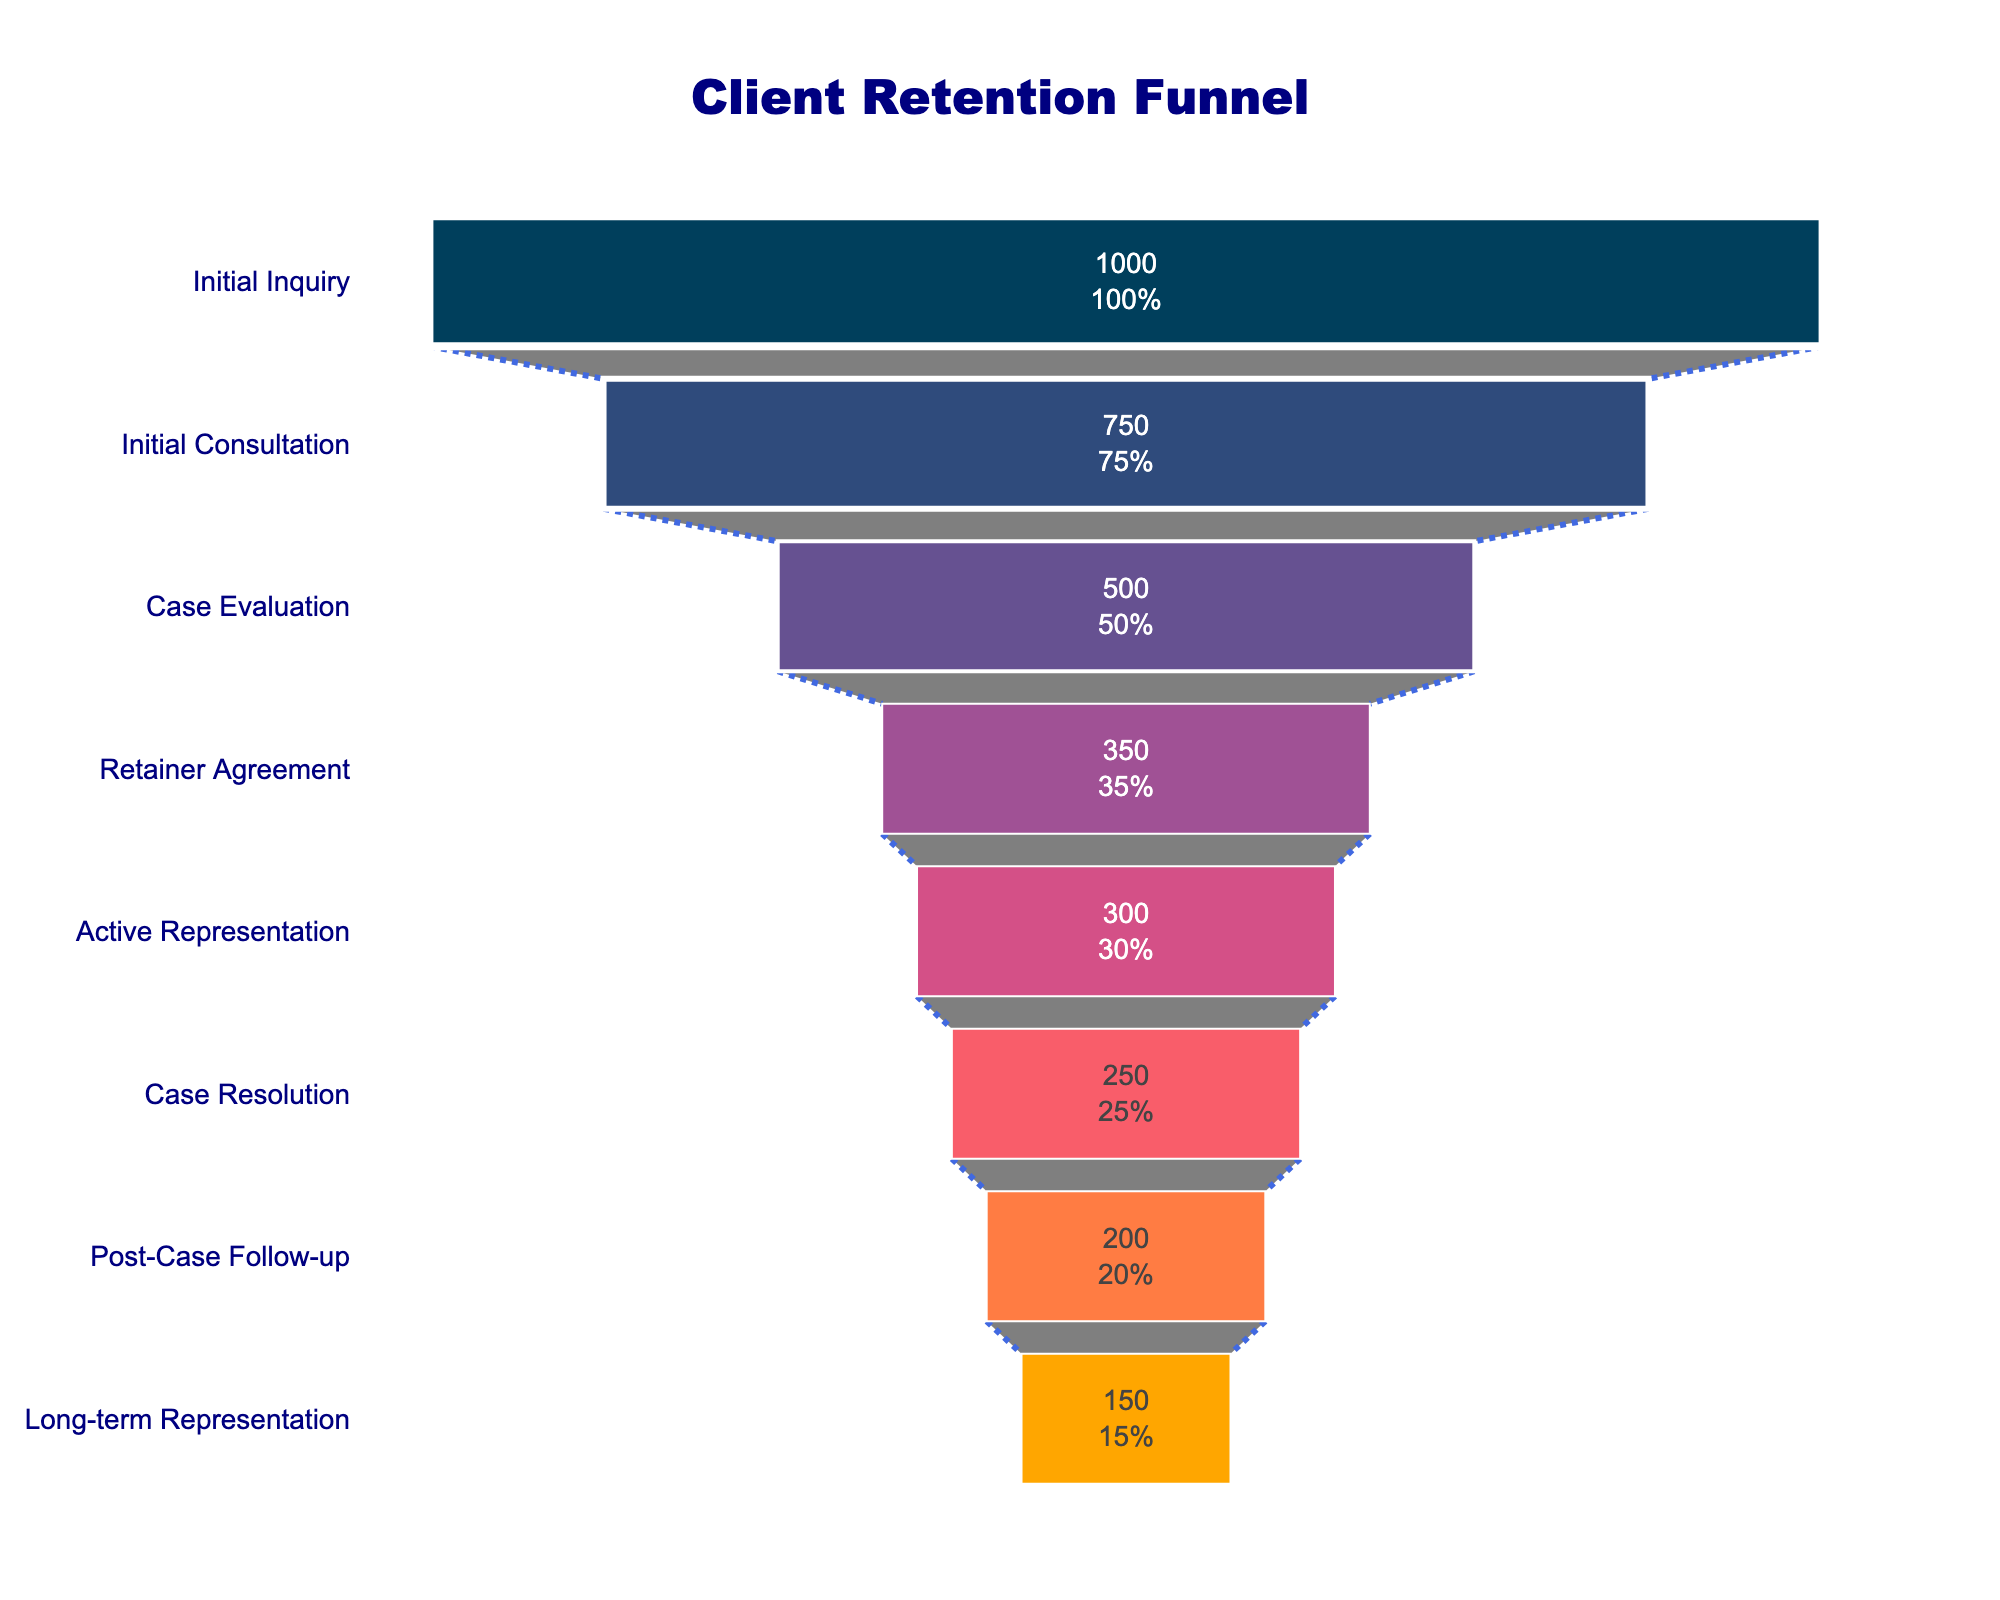What is the title of the funnel chart? The title of the chart is located at the top center. It reads "Client Retention Funnel" in a prominent font.
Answer: Client Retention Funnel How many stages are depicted in the funnel chart? The stages are listed in the funnel chart from top to bottom, indicating evolutionary steps. Counting these stages gives us the total number.
Answer: 8 What is the initial number of clients at the "Initial Inquiry" stage? The value inside the funnel chart at the "Initial Inquiry" stage shows the number of clients.
Answer: 1000 How many clients transition from the "Initial Consultation" to the "Case Evaluation" stage? The number of clients at the "Initial Consultation" stage is given as 750, and at the "Case Evaluation" stage, it is 500. The transition can be calculated by subtracting the number at "Case Evaluation" from "Initial Consultation". 750 - 500 = 250
Answer: 250 Which stage sees the largest drop in the number of clients between two consecutive stages? By comparing the drop in client numbers between each consecutive stage, the largest difference can be identified.
Answer: Initial Inquiry to Initial Consultation What percentage of clients from the "Initial Inquiry" stage reach the "Long-term Representation" stage? The number of clients at "Initial Inquiry" is 1000, and for "Long-term Representation," it is 150. The percentage is calculated as (150 / 1000) * 100 = 15%.
Answer: 15% How does the number of clients at the "Case Resolution" stage compare to the "Case Evaluation" stage? The value at the "Case Resolution" is 250, and the "Case Evaluation" is 500. The comparison can be done by observing these values.
Answer: The number of clients at the "Case Resolution" stage is lower than at the "Case Evaluation" stage What is the total drop in the number of clients from "Retainer Agreement" to "Active Representation"? The number of clients at "Retainer Agreement" is 350 and "Active Representation" is 300. The difference gives the total drop as 350 - 300 = 50.
Answer: 50 What is the average number of clients per stage in this funnel? Sum up the number of clients at all stages: 1000 + 750 + 500 + 350 + 300 + 250 + 200 + 150 = 3500. Then divide by the number of stages: 3500 / 8 = 437.5.
Answer: 437.5 Are there any stages where less than half of the initial clients remain? If so, which ones are they? Half of the initial 1000 clients is 500. Any stage with clients fewer than 500 qualifies. The stages below 500 clients are "Case Evaluation," "Retainer Agreement," "Active Representation," "Case Resolution," "Post-Case Follow-up," and "Long-term Representation."
Answer: Yes, Case Evaluation, Retainer Agreement, Active Representation, Case Resolution, Post-Case Follow-up, Long-term Representation 